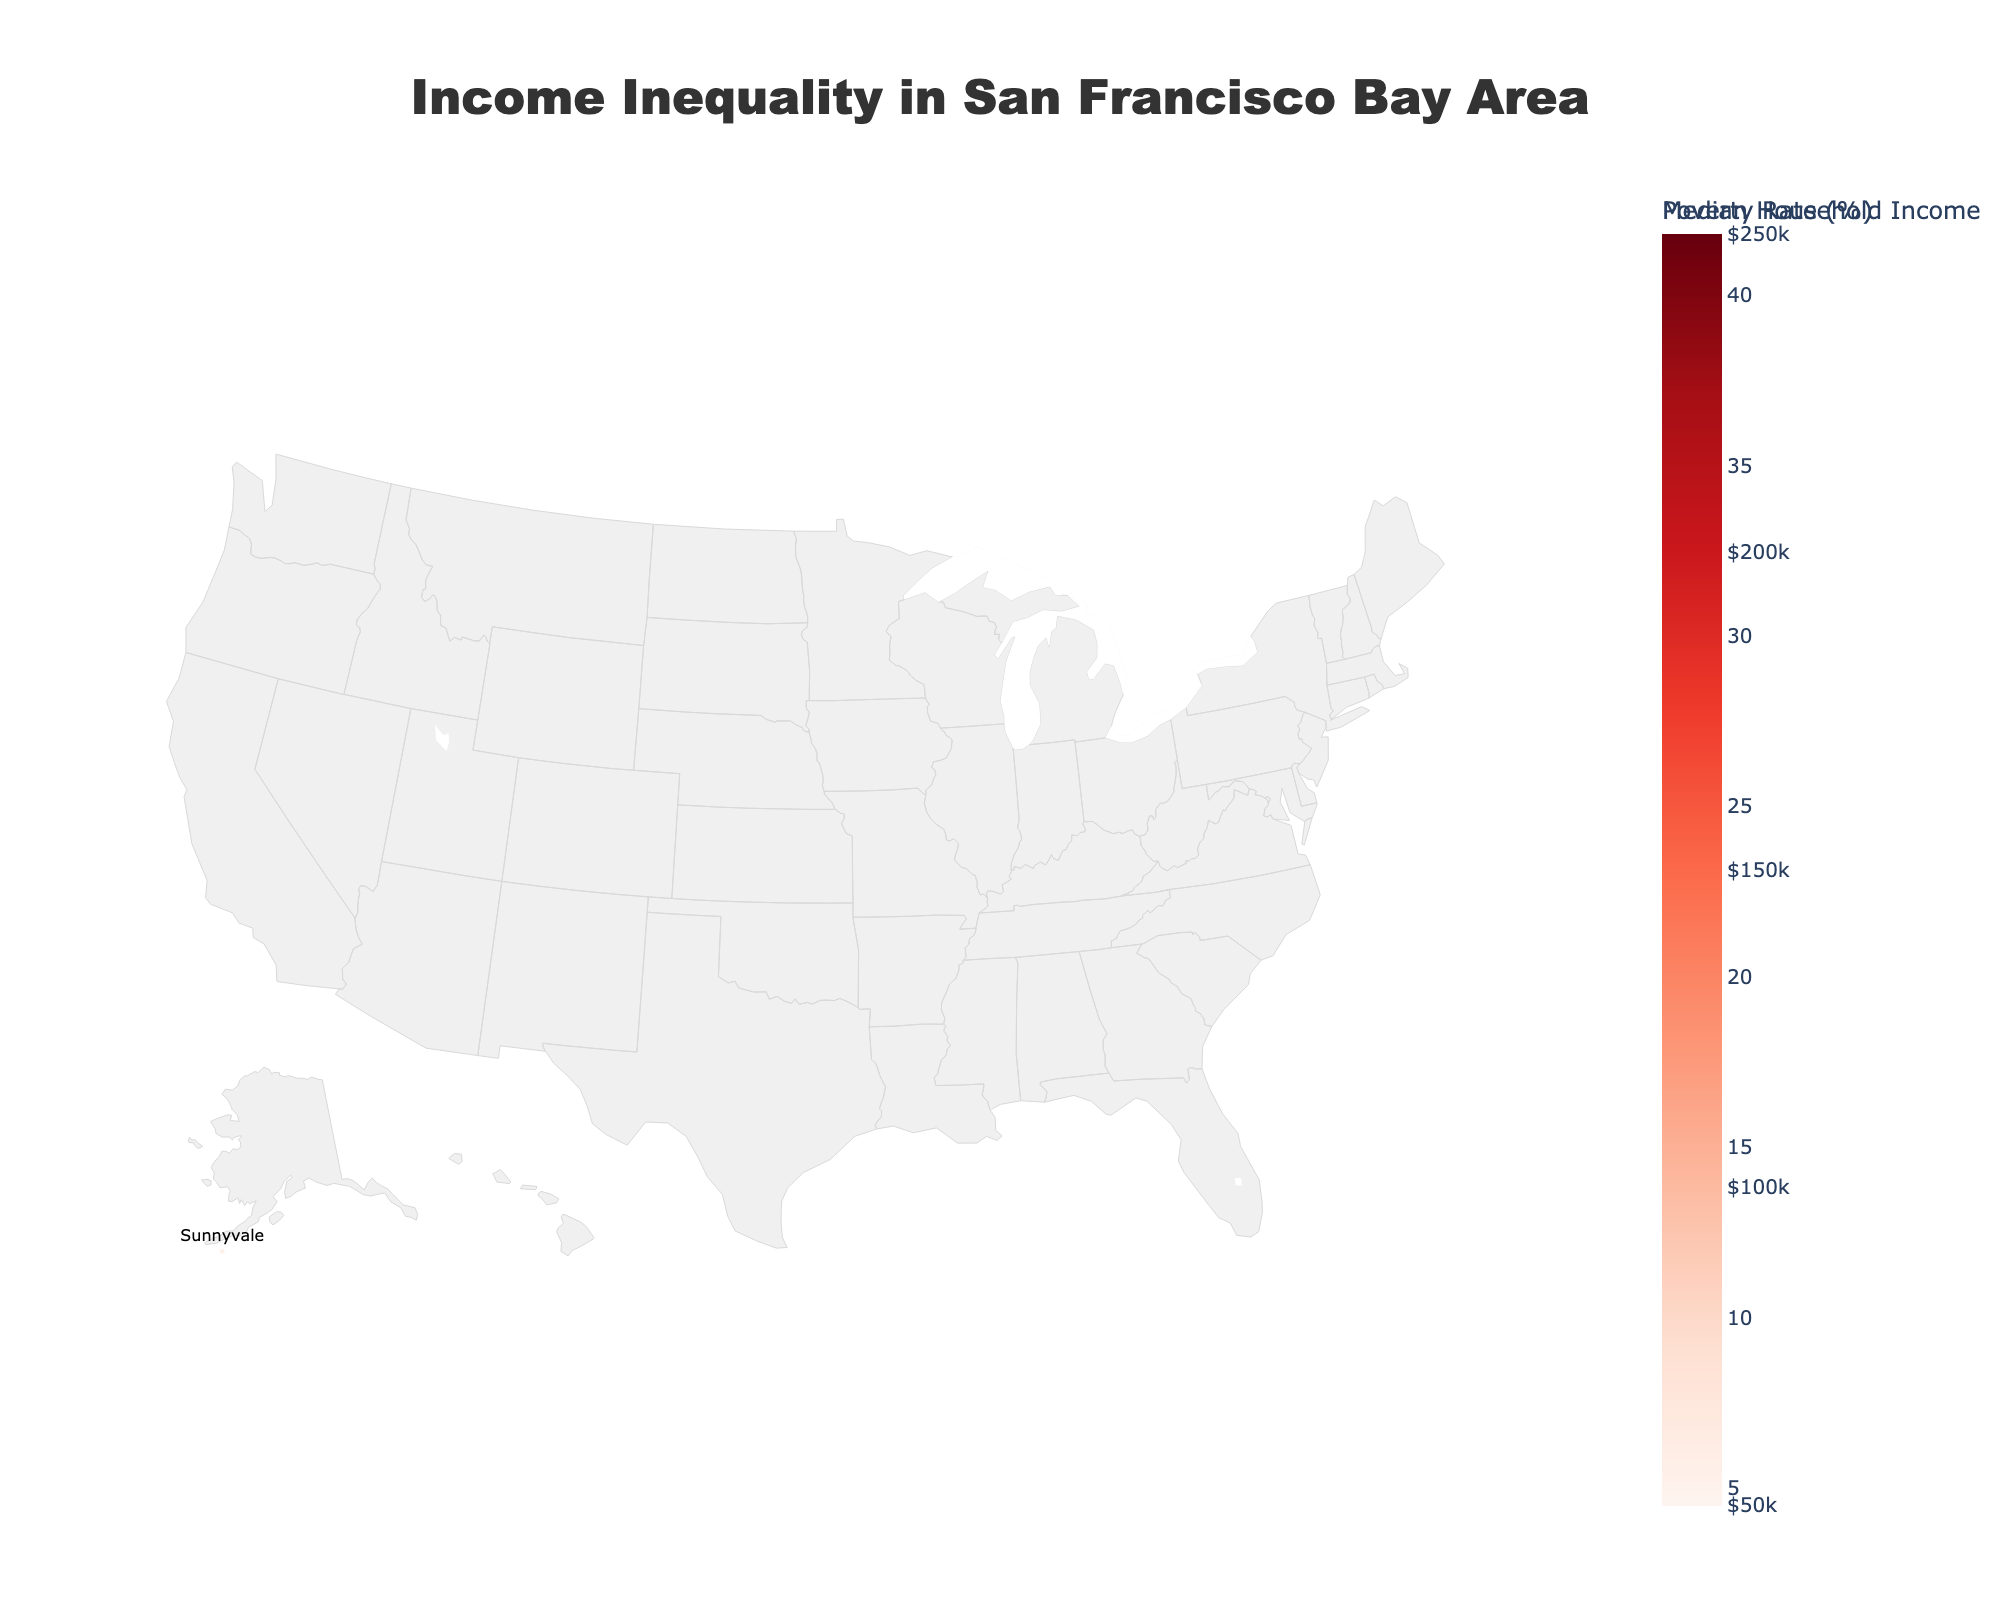What is the title of the plot? The title is located at the top center of the plot. It gives a brief description of what the plot is depicting.
Answer: Income Inequality in San Francisco Bay Area How many cities are visualized in the plot? Count the unique city names presented in the hover templates and scattered text.
Answer: 14 Which city has the highest median household income? By looking at the colors (darkest shades of the colors scale) and checking the hover templates for exact income values, you can identify the city with the highest figure.
Answer: Palo Alto What is the poverty rate in Berkeley's 94704 zip code? Refer to the hover template for the 94704 zip code, which lists the poverty rate along with other details.
Answer: 41.8% How does the median household income in Mountain View's 94041 zip code compare to that in Sunnyvale's 94086 zip code? Locate the hover templates for both zip codes and compare the listed median household incomes.
Answer: 174,000 vs. 140,000 What is the average median household income of San Francisco's zip codes shown in the plot? Sum the median household incomes of all the San Francisco zip codes and divide by the number of San Francisco zip codes. Calculation: (65,000 + 119,000 + 153,000) / 3
Answer: 112,333 Which city has both a high median household income and a low poverty rate? Look for cities with a dark color on the choropleth map (indicating high income) and smaller marker sizes on the scatter plot (indicating low poverty rates).
Answer: Fremont Is there a visible correlation between high median household income and low poverty rates across the zip codes? Observe if zip codes with darker colors (high income) generally have smaller-sized markers (lower poverty rates) on the scatter plot.
Answer: Yes Which zip code in San Francisco has the highest poverty rate? Compare the sizes of markers within San Francisco's zip codes and refer to their hover templates for accuracy.
Answer: 94102 What does the color and size of the markers represent? The color and size of markers are described in the plot's color scales and marker attributes.
Answer: Color represents poverty rate, size represents poverty rate (scaled) 